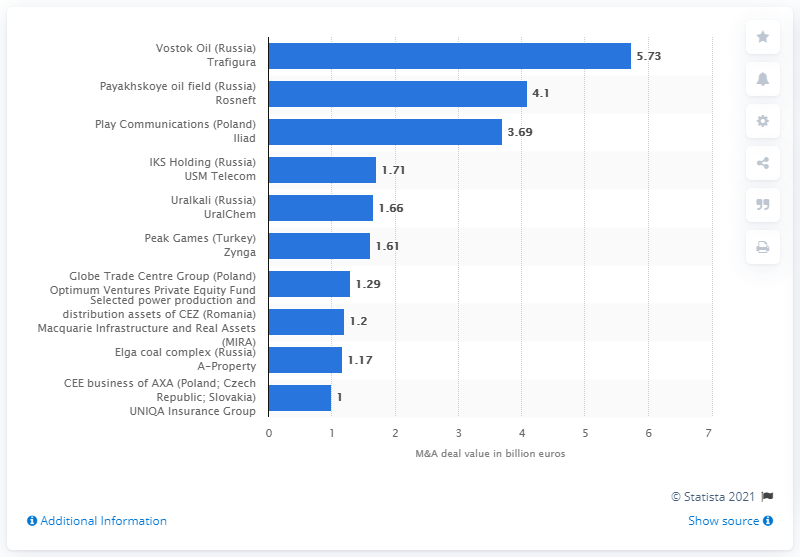Identify some key points in this picture. Trafigura acquired 1.61% of Vostok Oil in 2020. The highest blue bar represents Vostok Oil, a company based in Russia, and Trafigura, a commodities trader, as of a certain date. The second largest deal in Central and Eastern Europe amounted to 5.73... The average of the highest and lowest values in the chart is approximately 3.365. Trafigura's deal in Vostok Oil cost 5.73 million. 